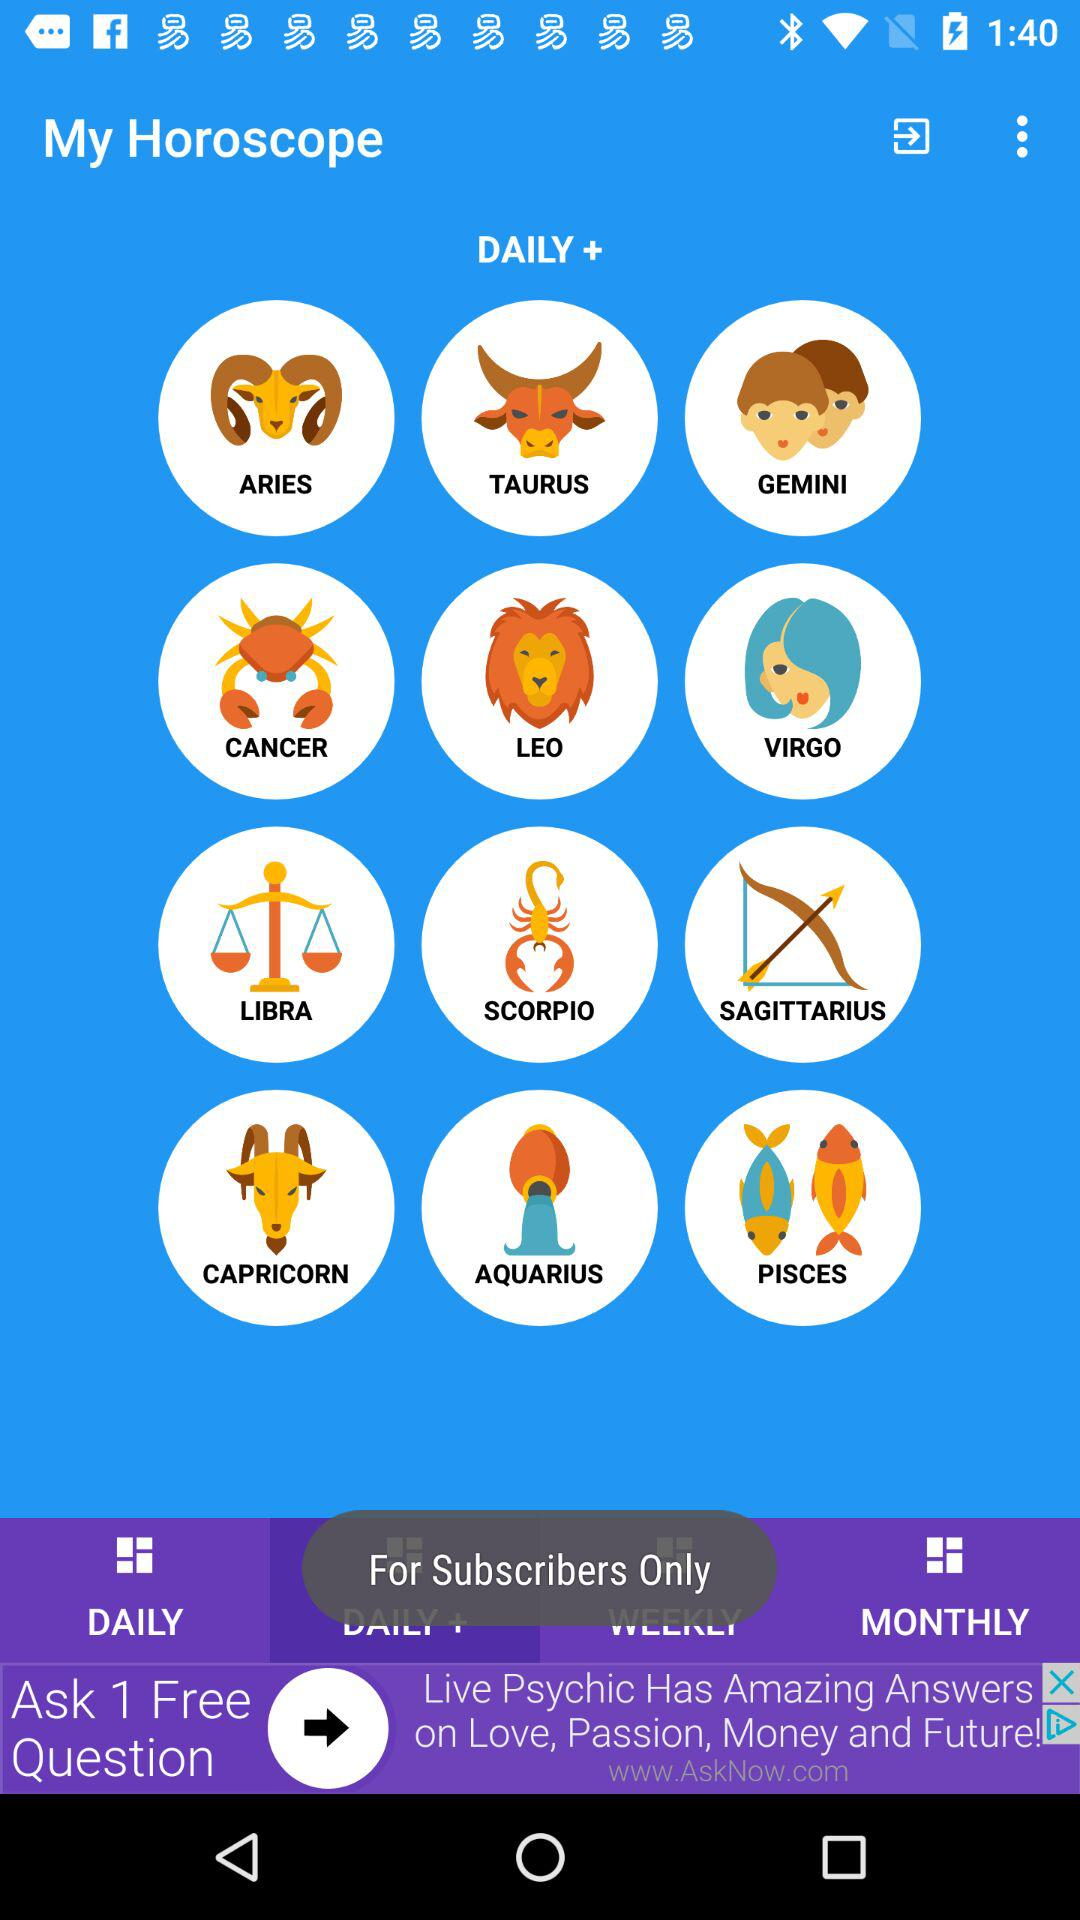Which tab is selected?
When the provided information is insufficient, respond with <no answer>. <no answer> 